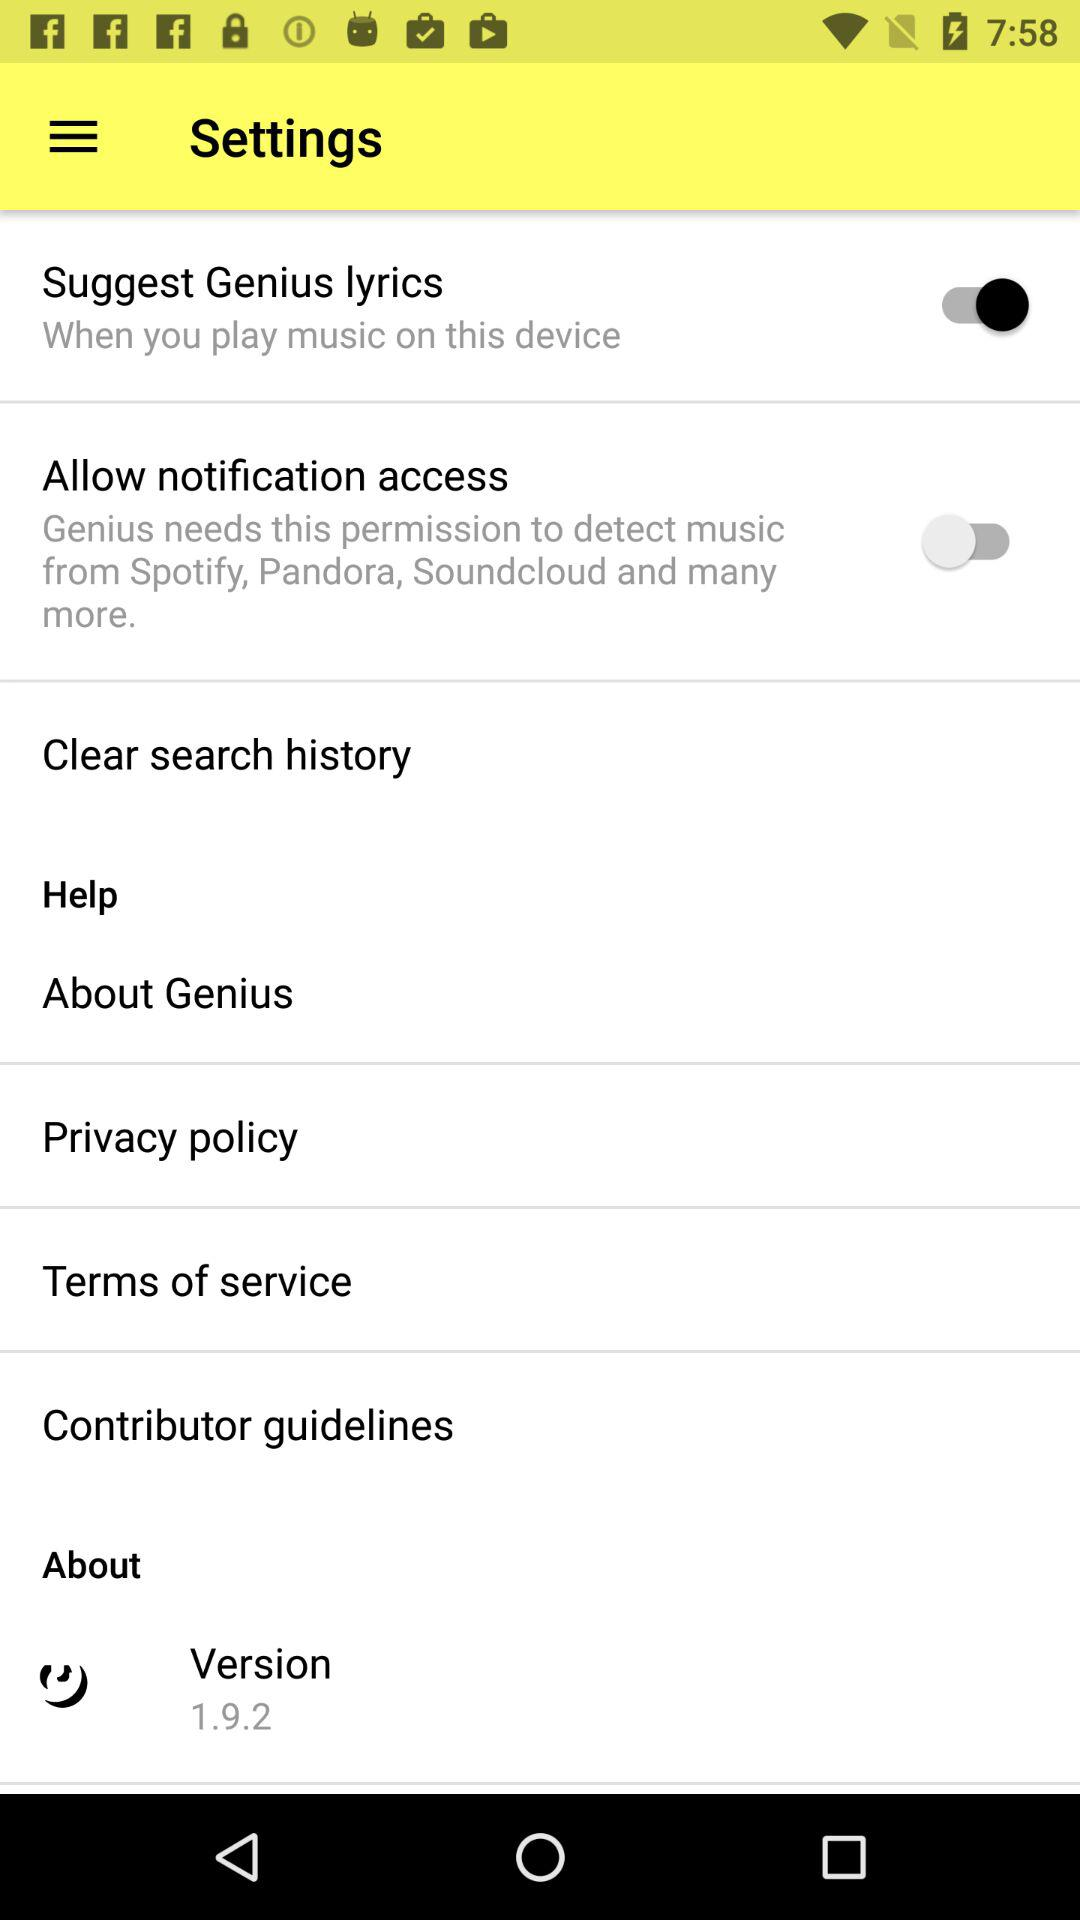What's the status of "Suggest Genius lyrics"? The status is "on". 